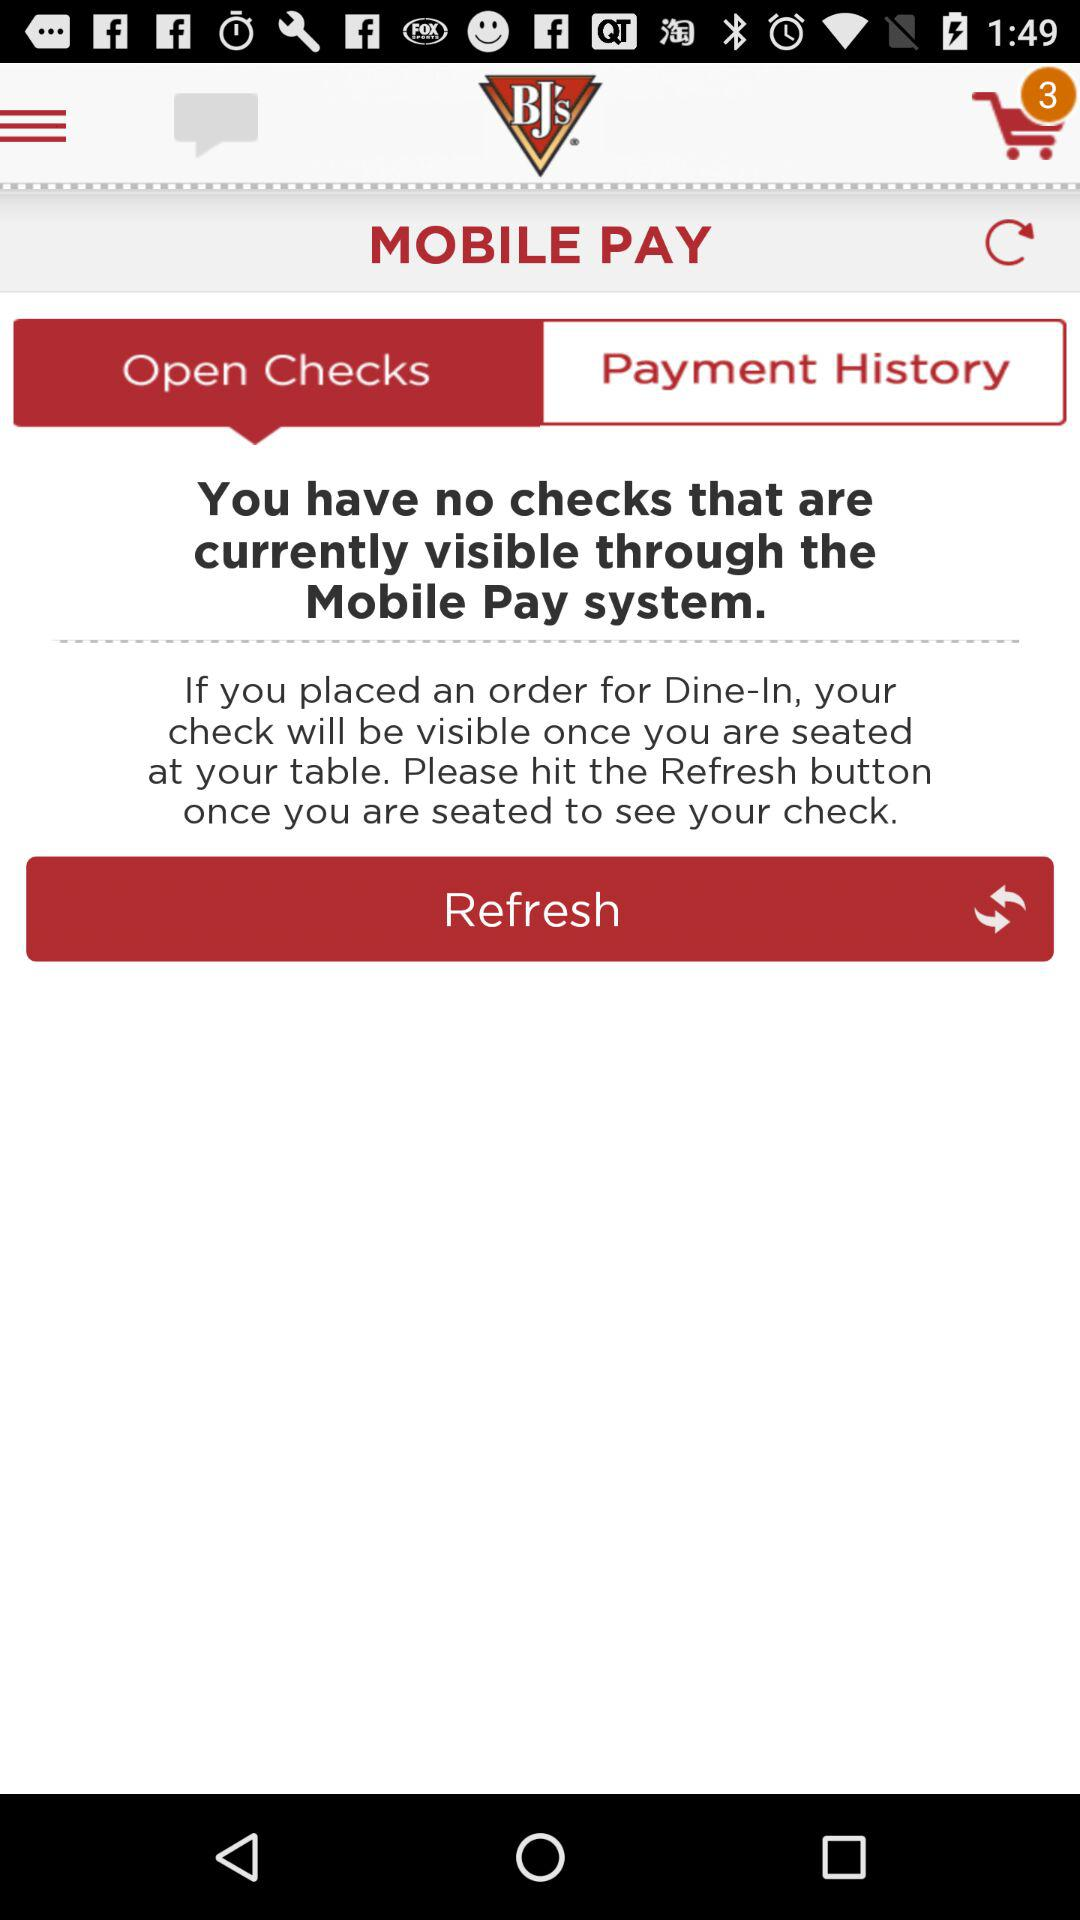How many checks do I have?
Answer the question using a single word or phrase. 0 